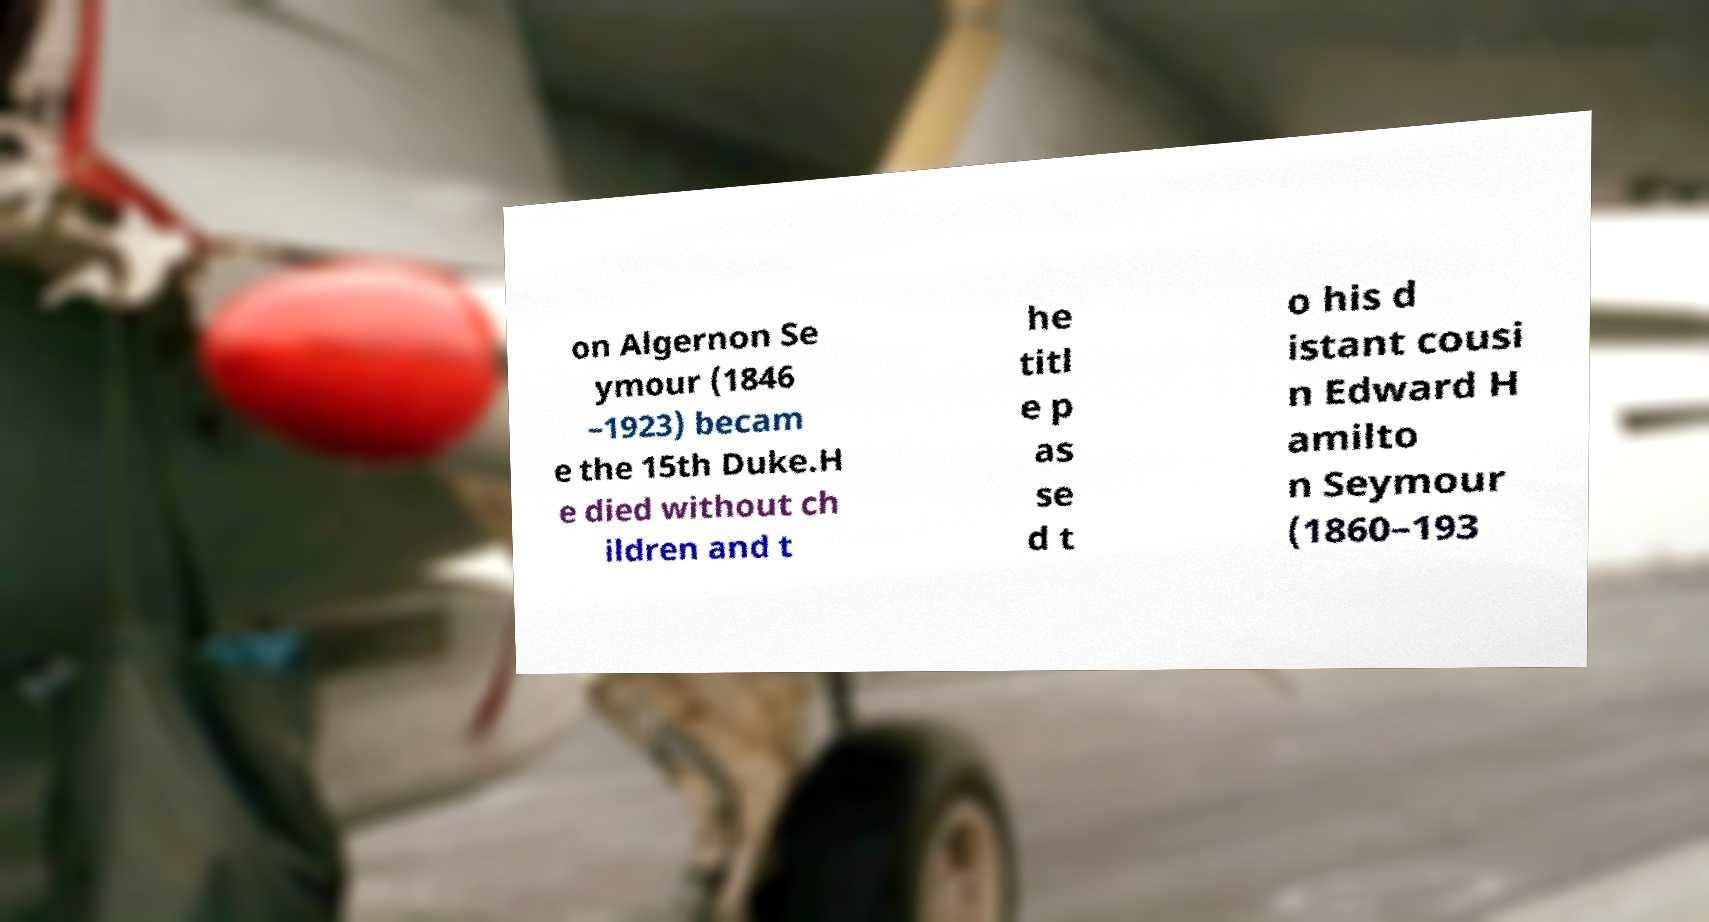Could you extract and type out the text from this image? on Algernon Se ymour (1846 –1923) becam e the 15th Duke.H e died without ch ildren and t he titl e p as se d t o his d istant cousi n Edward H amilto n Seymour (1860–193 